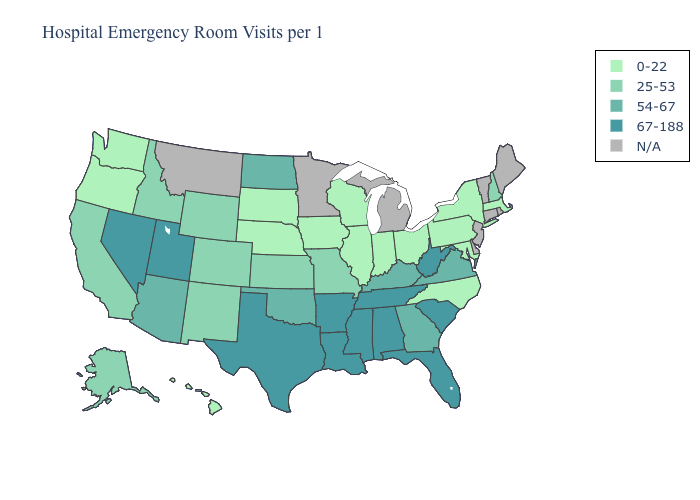Does the map have missing data?
Keep it brief. Yes. What is the value of New York?
Give a very brief answer. 0-22. Name the states that have a value in the range 67-188?
Be succinct. Alabama, Arkansas, Florida, Louisiana, Mississippi, Nevada, South Carolina, Tennessee, Texas, Utah, West Virginia. Name the states that have a value in the range 54-67?
Be succinct. Arizona, Georgia, Kentucky, North Dakota, Oklahoma, Virginia. Does the first symbol in the legend represent the smallest category?
Short answer required. Yes. What is the lowest value in the Northeast?
Give a very brief answer. 0-22. What is the value of Nevada?
Write a very short answer. 67-188. Which states have the highest value in the USA?
Be succinct. Alabama, Arkansas, Florida, Louisiana, Mississippi, Nevada, South Carolina, Tennessee, Texas, Utah, West Virginia. Among the states that border Oregon , does Washington have the lowest value?
Concise answer only. Yes. Is the legend a continuous bar?
Answer briefly. No. What is the highest value in the USA?
Concise answer only. 67-188. Name the states that have a value in the range 54-67?
Give a very brief answer. Arizona, Georgia, Kentucky, North Dakota, Oklahoma, Virginia. Among the states that border Washington , which have the highest value?
Short answer required. Idaho. Name the states that have a value in the range 54-67?
Keep it brief. Arizona, Georgia, Kentucky, North Dakota, Oklahoma, Virginia. 